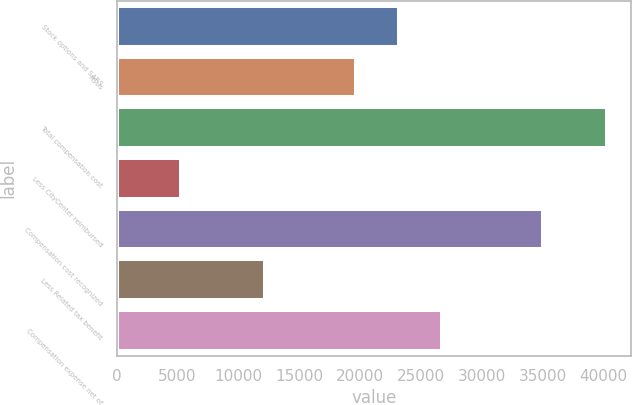<chart> <loc_0><loc_0><loc_500><loc_500><bar_chart><fcel>Stock options and SARS<fcel>RSUs<fcel>Total compensation cost<fcel>Less CityCenter reimbursed<fcel>Compensation cost recognized<fcel>Less Related tax benefit<fcel>Compensation expense net of<nl><fcel>23191.8<fcel>19693<fcel>40247<fcel>5259<fcel>34988<fcel>12162<fcel>26690.6<nl></chart> 